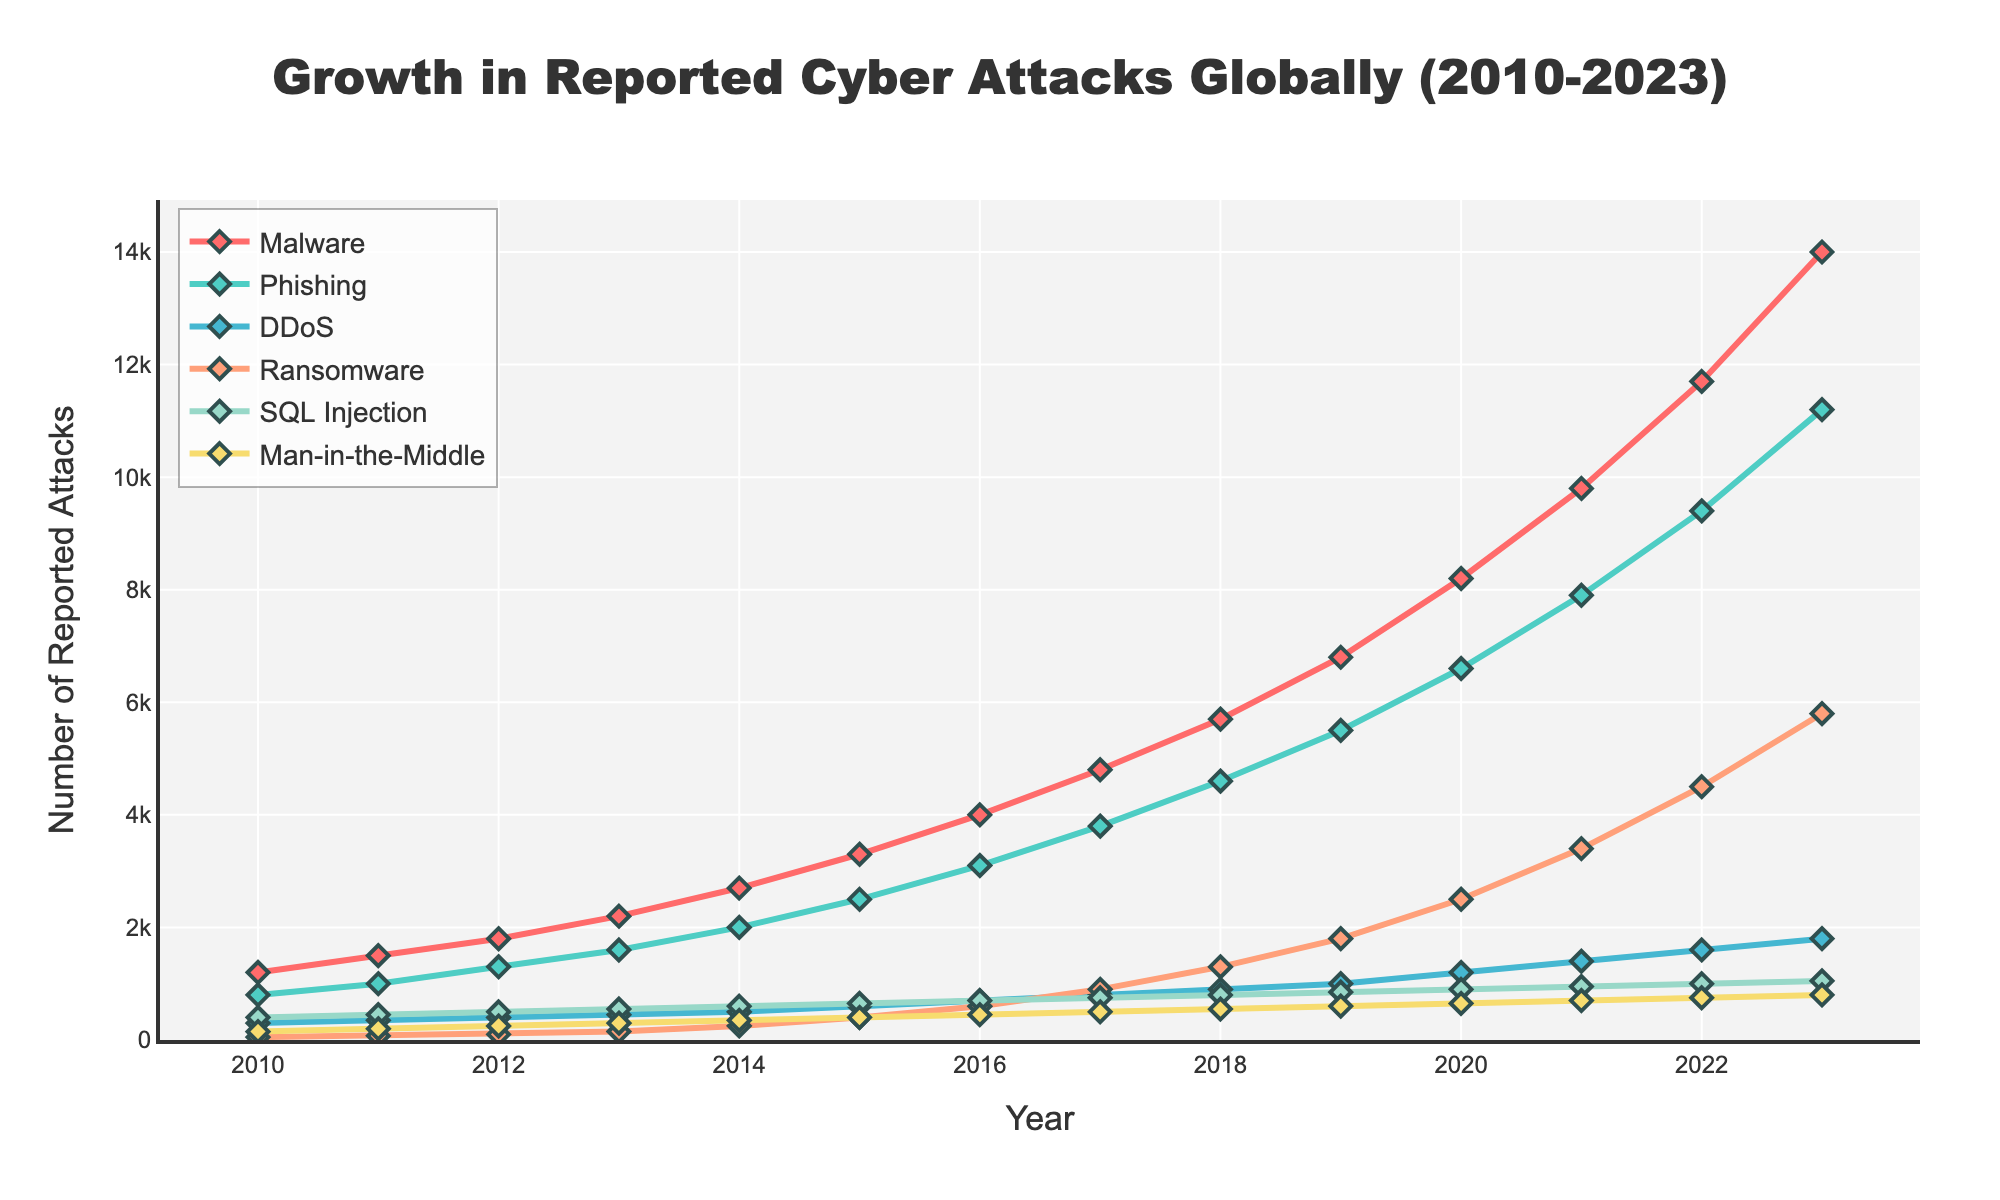What's the trend of malware attacks from 2010 to 2023? To identify the trend, observe the plotted line for malware attacks from 2010 to 2023. The number of reported malware attacks increases steadily each year, starting from 1200 in 2010 to 14000 in 2023.
Answer: Increasing Compare the reported phishing attacks in 2016 and 2023. Which year had more reported attacks and by how much? Look at the values for phishing attacks in 2016 (3100) and 2023 (11200). Subtract the 2016 value from the 2023 value to find the difference: 11200 - 3100 = 8100.
Answer: 2023, 8100 more Which year had the most reported SQL Injection attacks? To determine the year with the highest SQL Injection attacks, look at all the values and find the maximum value, which is 1050 in 2023.
Answer: 2023 By what percentage did ransomware attacks increase from 2016 to 2023? Find the ransomware attack values for 2016 (600) and 2023 (5800). Calculate the percentage increase using the formula: ((5800 - 600) / 600) * 100 = 866.67%.
Answer: 866.67% What's the difference in reported DDoS attacks between 2019 and 2020? Look at the DDoS attack values for 2019 (1000) and 2020 (1200). Subtract the 2019 value from the 2020 value: 1200 - 1000 = 200.
Answer: 200 If you combine the reported cases of ransomware and phishing in 2021, what is the total? Find the values for ransomware (3400) and phishing (7900) in 2021, and add them up: 3400 + 7900 = 11300.
Answer: 11300 What year did malware attacks surpass 6000 reported cases? Look at the trend of malware attacks and find the first year the value exceeds 6000, which happened in 2019 with 6800 reported cases.
Answer: 2019 Which attack type shows a consistent increase but remains the lowest in reported cases throughout the years? Observe all attack types and note their trends. Man-in-the-Middle attacks show a consistent increase but have the lowest reported cases each year, starting from 150 in 2010 and reaching 800 in 2023.
Answer: Man-in-the-Middle Comparing the visual colors, which line representing an attack type is green? Identify the green-colored line in the plot, which represents phishing attacks.
Answer: Phishing 